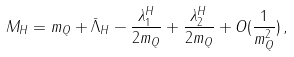Convert formula to latex. <formula><loc_0><loc_0><loc_500><loc_500>M _ { H } = m _ { Q } + \bar { \Lambda } _ { H } - \frac { \lambda _ { 1 } ^ { H } } { 2 m _ { Q } } + \frac { \lambda _ { 2 } ^ { H } } { 2 m _ { Q } } + O ( \frac { 1 } { m _ { Q } ^ { 2 } } ) \, ,</formula> 